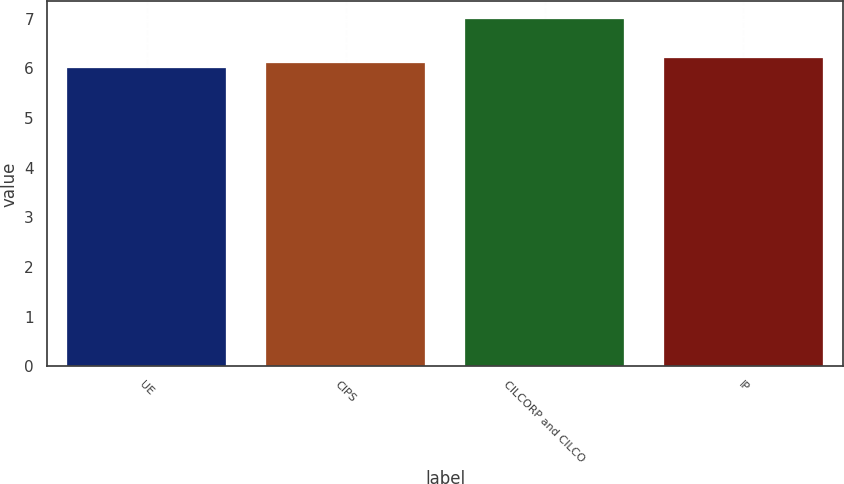Convert chart to OTSL. <chart><loc_0><loc_0><loc_500><loc_500><bar_chart><fcel>UE<fcel>CIPS<fcel>CILCORP and CILCO<fcel>IP<nl><fcel>6<fcel>6.1<fcel>7<fcel>6.2<nl></chart> 